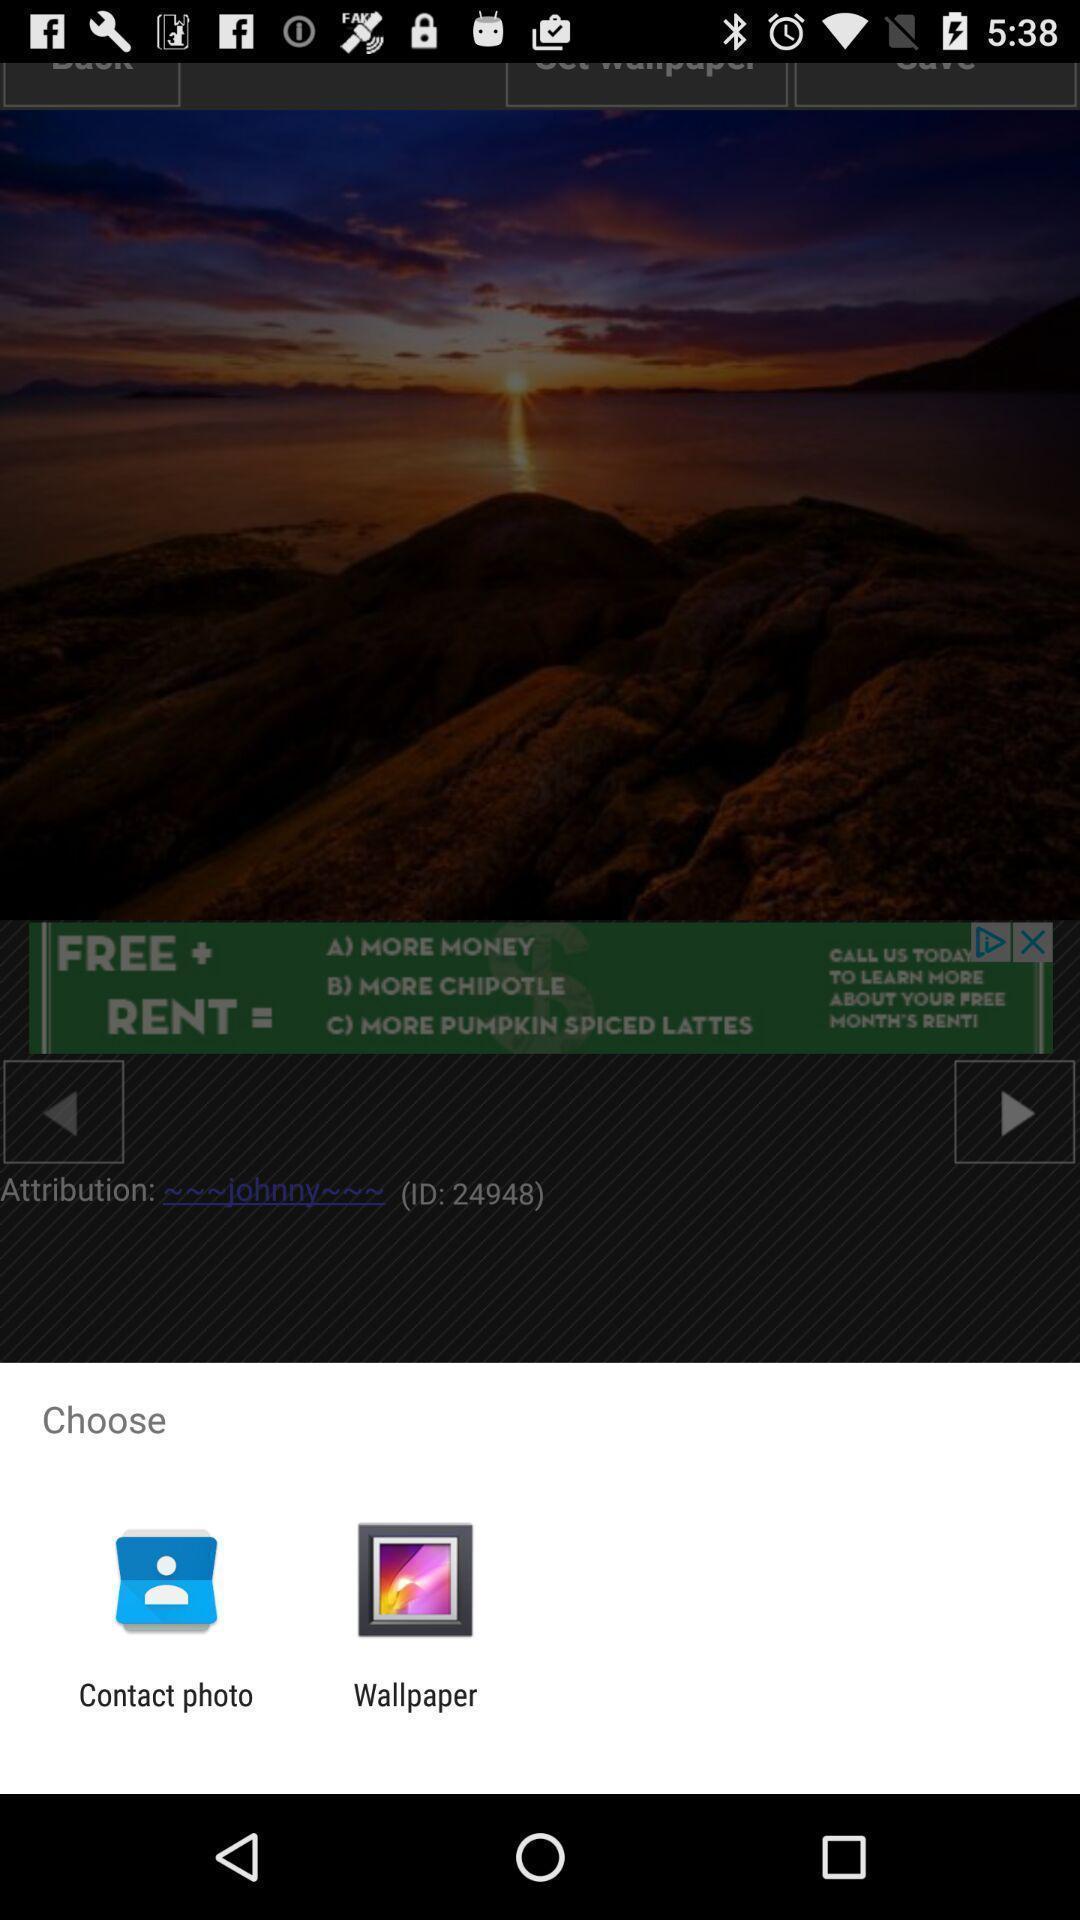Tell me about the visual elements in this screen capture. Pop-up for choosing contact photo or wallpaper. 